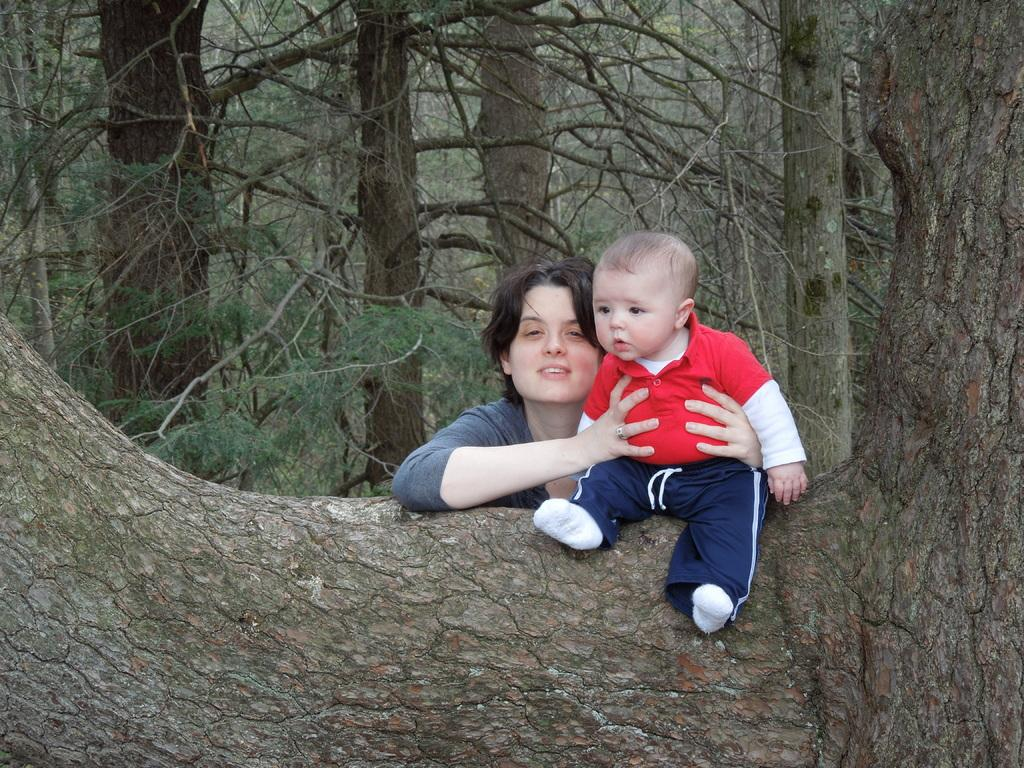Who is the main subject in the image? There is a woman in the image. What is the woman doing in the image? The woman is holding a baby boy. Where is the baby boy sitting in the image? The baby boy is sitting on a tree trunk. What can be seen in the background of the image? There are many trees visible in the background of the image. What type of oil is being used to fuel the nation in the image? There is no mention of oil or a nation in the image; it features a woman holding a baby boy sitting on a tree trunk with trees in the background. 